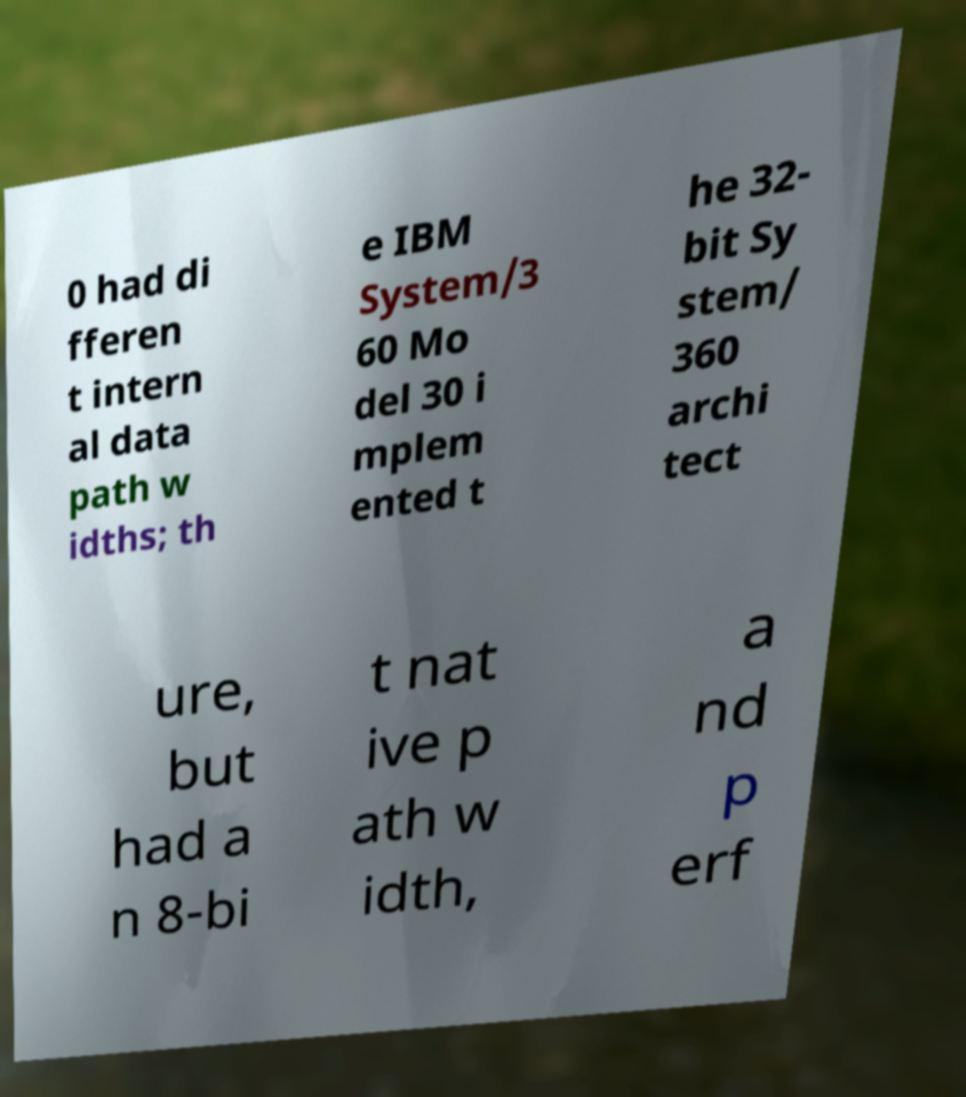What messages or text are displayed in this image? I need them in a readable, typed format. 0 had di fferen t intern al data path w idths; th e IBM System/3 60 Mo del 30 i mplem ented t he 32- bit Sy stem/ 360 archi tect ure, but had a n 8-bi t nat ive p ath w idth, a nd p erf 